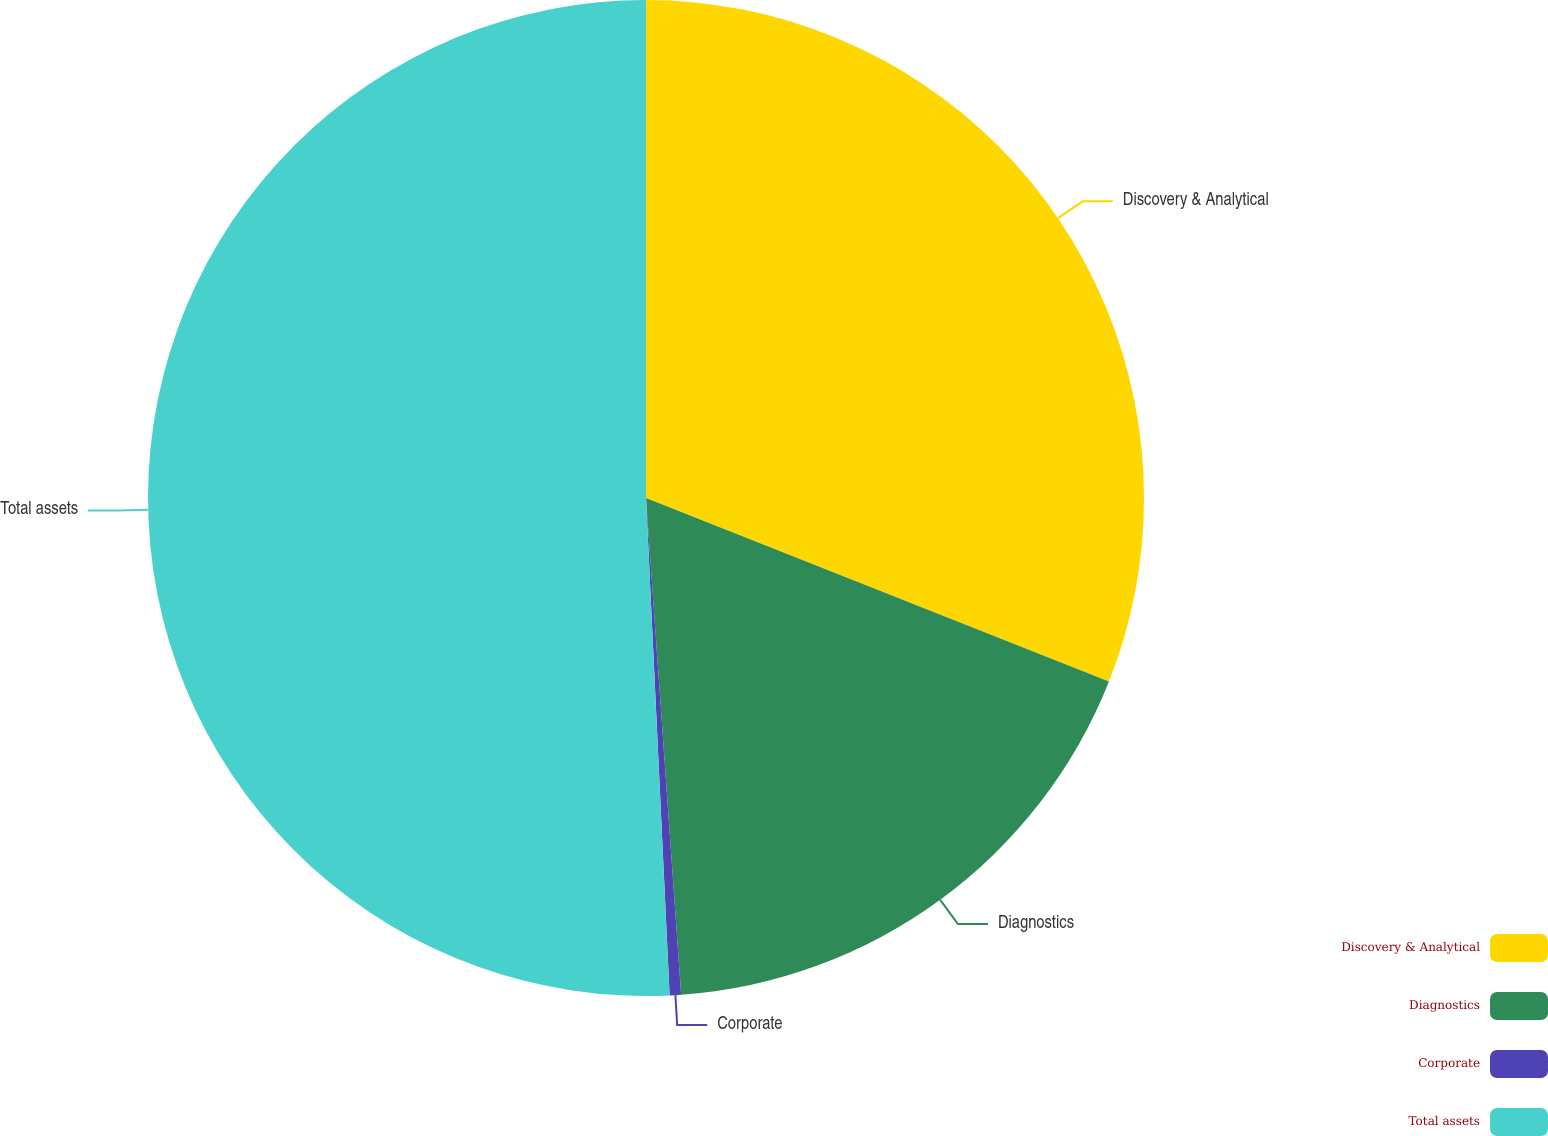<chart> <loc_0><loc_0><loc_500><loc_500><pie_chart><fcel>Discovery & Analytical<fcel>Diagnostics<fcel>Corporate<fcel>Total assets<nl><fcel>31.01%<fcel>17.87%<fcel>0.37%<fcel>50.76%<nl></chart> 